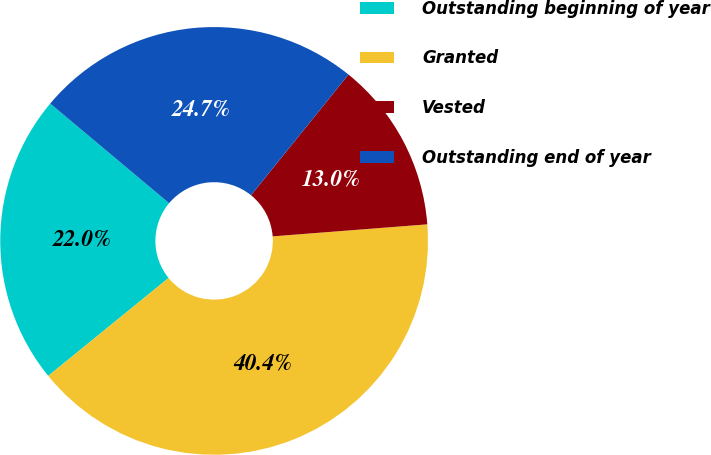Convert chart. <chart><loc_0><loc_0><loc_500><loc_500><pie_chart><fcel>Outstanding beginning of year<fcel>Granted<fcel>Vested<fcel>Outstanding end of year<nl><fcel>21.97%<fcel>40.36%<fcel>12.95%<fcel>24.71%<nl></chart> 